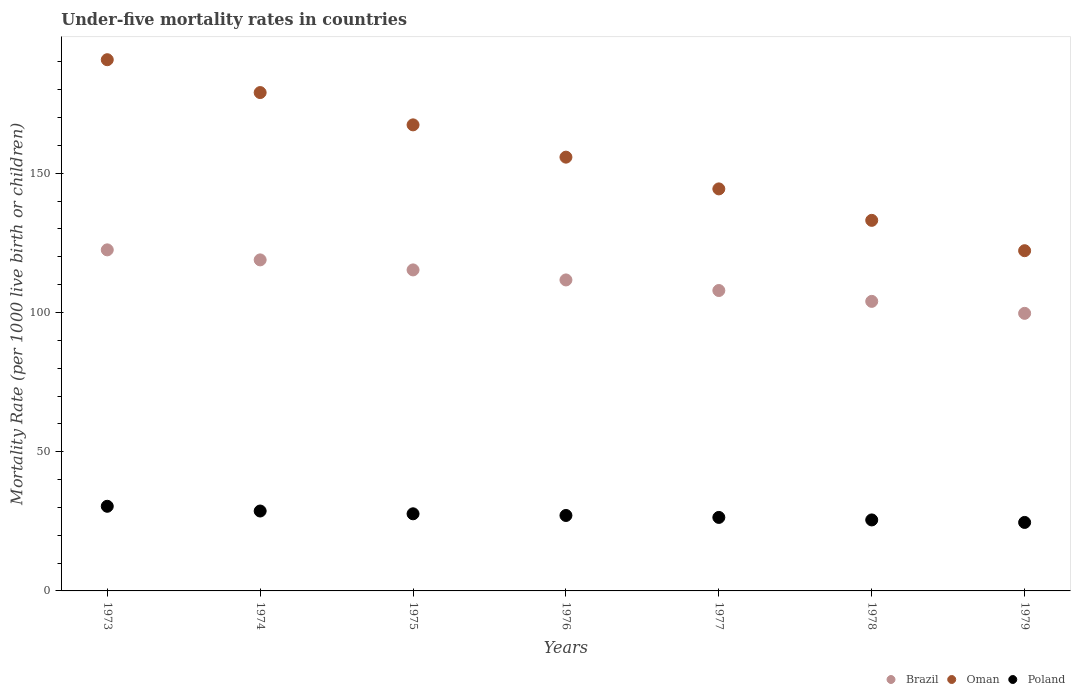How many different coloured dotlines are there?
Make the answer very short. 3. What is the under-five mortality rate in Brazil in 1973?
Your answer should be compact. 122.5. Across all years, what is the maximum under-five mortality rate in Oman?
Provide a succinct answer. 190.8. Across all years, what is the minimum under-five mortality rate in Brazil?
Offer a very short reply. 99.7. In which year was the under-five mortality rate in Oman minimum?
Provide a short and direct response. 1979. What is the total under-five mortality rate in Oman in the graph?
Offer a very short reply. 1092.7. What is the difference between the under-five mortality rate in Poland in 1975 and that in 1978?
Keep it short and to the point. 2.2. What is the difference between the under-five mortality rate in Oman in 1978 and the under-five mortality rate in Brazil in 1974?
Keep it short and to the point. 14.2. What is the average under-five mortality rate in Brazil per year?
Ensure brevity in your answer.  111.43. In the year 1977, what is the difference between the under-five mortality rate in Oman and under-five mortality rate in Brazil?
Your answer should be compact. 36.5. What is the ratio of the under-five mortality rate in Oman in 1975 to that in 1979?
Your answer should be compact. 1.37. What is the difference between the highest and the second highest under-five mortality rate in Poland?
Make the answer very short. 1.7. What is the difference between the highest and the lowest under-five mortality rate in Brazil?
Offer a very short reply. 22.8. Is the under-five mortality rate in Oman strictly greater than the under-five mortality rate in Poland over the years?
Give a very brief answer. Yes. What is the difference between two consecutive major ticks on the Y-axis?
Make the answer very short. 50. Does the graph contain any zero values?
Offer a very short reply. No. Does the graph contain grids?
Make the answer very short. No. Where does the legend appear in the graph?
Keep it short and to the point. Bottom right. How many legend labels are there?
Your answer should be very brief. 3. What is the title of the graph?
Your answer should be very brief. Under-five mortality rates in countries. Does "Tajikistan" appear as one of the legend labels in the graph?
Ensure brevity in your answer.  No. What is the label or title of the Y-axis?
Offer a terse response. Mortality Rate (per 1000 live birth or children). What is the Mortality Rate (per 1000 live birth or children) in Brazil in 1973?
Your answer should be very brief. 122.5. What is the Mortality Rate (per 1000 live birth or children) of Oman in 1973?
Your answer should be compact. 190.8. What is the Mortality Rate (per 1000 live birth or children) in Poland in 1973?
Offer a terse response. 30.4. What is the Mortality Rate (per 1000 live birth or children) of Brazil in 1974?
Your response must be concise. 118.9. What is the Mortality Rate (per 1000 live birth or children) of Oman in 1974?
Make the answer very short. 179. What is the Mortality Rate (per 1000 live birth or children) of Poland in 1974?
Keep it short and to the point. 28.7. What is the Mortality Rate (per 1000 live birth or children) of Brazil in 1975?
Offer a very short reply. 115.3. What is the Mortality Rate (per 1000 live birth or children) of Oman in 1975?
Your answer should be compact. 167.4. What is the Mortality Rate (per 1000 live birth or children) in Poland in 1975?
Your answer should be very brief. 27.7. What is the Mortality Rate (per 1000 live birth or children) of Brazil in 1976?
Offer a very short reply. 111.7. What is the Mortality Rate (per 1000 live birth or children) of Oman in 1976?
Your response must be concise. 155.8. What is the Mortality Rate (per 1000 live birth or children) of Poland in 1976?
Your response must be concise. 27.1. What is the Mortality Rate (per 1000 live birth or children) in Brazil in 1977?
Offer a terse response. 107.9. What is the Mortality Rate (per 1000 live birth or children) in Oman in 1977?
Your answer should be compact. 144.4. What is the Mortality Rate (per 1000 live birth or children) of Poland in 1977?
Offer a very short reply. 26.4. What is the Mortality Rate (per 1000 live birth or children) in Brazil in 1978?
Offer a very short reply. 104. What is the Mortality Rate (per 1000 live birth or children) in Oman in 1978?
Offer a terse response. 133.1. What is the Mortality Rate (per 1000 live birth or children) in Brazil in 1979?
Offer a very short reply. 99.7. What is the Mortality Rate (per 1000 live birth or children) in Oman in 1979?
Offer a very short reply. 122.2. What is the Mortality Rate (per 1000 live birth or children) of Poland in 1979?
Your answer should be very brief. 24.6. Across all years, what is the maximum Mortality Rate (per 1000 live birth or children) of Brazil?
Offer a very short reply. 122.5. Across all years, what is the maximum Mortality Rate (per 1000 live birth or children) in Oman?
Offer a very short reply. 190.8. Across all years, what is the maximum Mortality Rate (per 1000 live birth or children) of Poland?
Your answer should be very brief. 30.4. Across all years, what is the minimum Mortality Rate (per 1000 live birth or children) in Brazil?
Offer a terse response. 99.7. Across all years, what is the minimum Mortality Rate (per 1000 live birth or children) in Oman?
Make the answer very short. 122.2. Across all years, what is the minimum Mortality Rate (per 1000 live birth or children) of Poland?
Your answer should be compact. 24.6. What is the total Mortality Rate (per 1000 live birth or children) of Brazil in the graph?
Provide a short and direct response. 780. What is the total Mortality Rate (per 1000 live birth or children) of Oman in the graph?
Offer a terse response. 1092.7. What is the total Mortality Rate (per 1000 live birth or children) in Poland in the graph?
Give a very brief answer. 190.4. What is the difference between the Mortality Rate (per 1000 live birth or children) of Brazil in 1973 and that in 1974?
Offer a terse response. 3.6. What is the difference between the Mortality Rate (per 1000 live birth or children) in Oman in 1973 and that in 1974?
Make the answer very short. 11.8. What is the difference between the Mortality Rate (per 1000 live birth or children) of Poland in 1973 and that in 1974?
Give a very brief answer. 1.7. What is the difference between the Mortality Rate (per 1000 live birth or children) in Oman in 1973 and that in 1975?
Provide a short and direct response. 23.4. What is the difference between the Mortality Rate (per 1000 live birth or children) in Poland in 1973 and that in 1976?
Your answer should be very brief. 3.3. What is the difference between the Mortality Rate (per 1000 live birth or children) in Oman in 1973 and that in 1977?
Offer a terse response. 46.4. What is the difference between the Mortality Rate (per 1000 live birth or children) of Poland in 1973 and that in 1977?
Provide a succinct answer. 4. What is the difference between the Mortality Rate (per 1000 live birth or children) of Brazil in 1973 and that in 1978?
Give a very brief answer. 18.5. What is the difference between the Mortality Rate (per 1000 live birth or children) of Oman in 1973 and that in 1978?
Offer a very short reply. 57.7. What is the difference between the Mortality Rate (per 1000 live birth or children) in Poland in 1973 and that in 1978?
Give a very brief answer. 4.9. What is the difference between the Mortality Rate (per 1000 live birth or children) of Brazil in 1973 and that in 1979?
Make the answer very short. 22.8. What is the difference between the Mortality Rate (per 1000 live birth or children) in Oman in 1973 and that in 1979?
Offer a terse response. 68.6. What is the difference between the Mortality Rate (per 1000 live birth or children) of Poland in 1973 and that in 1979?
Provide a succinct answer. 5.8. What is the difference between the Mortality Rate (per 1000 live birth or children) of Brazil in 1974 and that in 1975?
Ensure brevity in your answer.  3.6. What is the difference between the Mortality Rate (per 1000 live birth or children) in Oman in 1974 and that in 1975?
Your response must be concise. 11.6. What is the difference between the Mortality Rate (per 1000 live birth or children) of Poland in 1974 and that in 1975?
Ensure brevity in your answer.  1. What is the difference between the Mortality Rate (per 1000 live birth or children) of Oman in 1974 and that in 1976?
Keep it short and to the point. 23.2. What is the difference between the Mortality Rate (per 1000 live birth or children) in Oman in 1974 and that in 1977?
Your response must be concise. 34.6. What is the difference between the Mortality Rate (per 1000 live birth or children) of Brazil in 1974 and that in 1978?
Your answer should be compact. 14.9. What is the difference between the Mortality Rate (per 1000 live birth or children) in Oman in 1974 and that in 1978?
Your response must be concise. 45.9. What is the difference between the Mortality Rate (per 1000 live birth or children) of Poland in 1974 and that in 1978?
Offer a very short reply. 3.2. What is the difference between the Mortality Rate (per 1000 live birth or children) of Oman in 1974 and that in 1979?
Give a very brief answer. 56.8. What is the difference between the Mortality Rate (per 1000 live birth or children) in Poland in 1974 and that in 1979?
Provide a short and direct response. 4.1. What is the difference between the Mortality Rate (per 1000 live birth or children) of Oman in 1975 and that in 1976?
Ensure brevity in your answer.  11.6. What is the difference between the Mortality Rate (per 1000 live birth or children) in Brazil in 1975 and that in 1977?
Offer a very short reply. 7.4. What is the difference between the Mortality Rate (per 1000 live birth or children) in Oman in 1975 and that in 1978?
Give a very brief answer. 34.3. What is the difference between the Mortality Rate (per 1000 live birth or children) of Brazil in 1975 and that in 1979?
Your answer should be very brief. 15.6. What is the difference between the Mortality Rate (per 1000 live birth or children) of Oman in 1975 and that in 1979?
Offer a terse response. 45.2. What is the difference between the Mortality Rate (per 1000 live birth or children) in Poland in 1975 and that in 1979?
Offer a very short reply. 3.1. What is the difference between the Mortality Rate (per 1000 live birth or children) in Brazil in 1976 and that in 1977?
Your answer should be very brief. 3.8. What is the difference between the Mortality Rate (per 1000 live birth or children) in Poland in 1976 and that in 1977?
Make the answer very short. 0.7. What is the difference between the Mortality Rate (per 1000 live birth or children) of Brazil in 1976 and that in 1978?
Your answer should be compact. 7.7. What is the difference between the Mortality Rate (per 1000 live birth or children) of Oman in 1976 and that in 1978?
Give a very brief answer. 22.7. What is the difference between the Mortality Rate (per 1000 live birth or children) in Oman in 1976 and that in 1979?
Your answer should be compact. 33.6. What is the difference between the Mortality Rate (per 1000 live birth or children) of Poland in 1976 and that in 1979?
Give a very brief answer. 2.5. What is the difference between the Mortality Rate (per 1000 live birth or children) in Oman in 1977 and that in 1978?
Your response must be concise. 11.3. What is the difference between the Mortality Rate (per 1000 live birth or children) of Poland in 1977 and that in 1978?
Ensure brevity in your answer.  0.9. What is the difference between the Mortality Rate (per 1000 live birth or children) of Brazil in 1977 and that in 1979?
Provide a short and direct response. 8.2. What is the difference between the Mortality Rate (per 1000 live birth or children) of Poland in 1977 and that in 1979?
Your response must be concise. 1.8. What is the difference between the Mortality Rate (per 1000 live birth or children) of Brazil in 1978 and that in 1979?
Make the answer very short. 4.3. What is the difference between the Mortality Rate (per 1000 live birth or children) in Brazil in 1973 and the Mortality Rate (per 1000 live birth or children) in Oman in 1974?
Ensure brevity in your answer.  -56.5. What is the difference between the Mortality Rate (per 1000 live birth or children) in Brazil in 1973 and the Mortality Rate (per 1000 live birth or children) in Poland in 1974?
Ensure brevity in your answer.  93.8. What is the difference between the Mortality Rate (per 1000 live birth or children) in Oman in 1973 and the Mortality Rate (per 1000 live birth or children) in Poland in 1974?
Give a very brief answer. 162.1. What is the difference between the Mortality Rate (per 1000 live birth or children) of Brazil in 1973 and the Mortality Rate (per 1000 live birth or children) of Oman in 1975?
Provide a succinct answer. -44.9. What is the difference between the Mortality Rate (per 1000 live birth or children) of Brazil in 1973 and the Mortality Rate (per 1000 live birth or children) of Poland in 1975?
Your response must be concise. 94.8. What is the difference between the Mortality Rate (per 1000 live birth or children) of Oman in 1973 and the Mortality Rate (per 1000 live birth or children) of Poland in 1975?
Offer a very short reply. 163.1. What is the difference between the Mortality Rate (per 1000 live birth or children) of Brazil in 1973 and the Mortality Rate (per 1000 live birth or children) of Oman in 1976?
Provide a succinct answer. -33.3. What is the difference between the Mortality Rate (per 1000 live birth or children) of Brazil in 1973 and the Mortality Rate (per 1000 live birth or children) of Poland in 1976?
Give a very brief answer. 95.4. What is the difference between the Mortality Rate (per 1000 live birth or children) in Oman in 1973 and the Mortality Rate (per 1000 live birth or children) in Poland in 1976?
Keep it short and to the point. 163.7. What is the difference between the Mortality Rate (per 1000 live birth or children) of Brazil in 1973 and the Mortality Rate (per 1000 live birth or children) of Oman in 1977?
Offer a very short reply. -21.9. What is the difference between the Mortality Rate (per 1000 live birth or children) of Brazil in 1973 and the Mortality Rate (per 1000 live birth or children) of Poland in 1977?
Give a very brief answer. 96.1. What is the difference between the Mortality Rate (per 1000 live birth or children) in Oman in 1973 and the Mortality Rate (per 1000 live birth or children) in Poland in 1977?
Your answer should be compact. 164.4. What is the difference between the Mortality Rate (per 1000 live birth or children) in Brazil in 1973 and the Mortality Rate (per 1000 live birth or children) in Oman in 1978?
Keep it short and to the point. -10.6. What is the difference between the Mortality Rate (per 1000 live birth or children) in Brazil in 1973 and the Mortality Rate (per 1000 live birth or children) in Poland in 1978?
Provide a succinct answer. 97. What is the difference between the Mortality Rate (per 1000 live birth or children) of Oman in 1973 and the Mortality Rate (per 1000 live birth or children) of Poland in 1978?
Keep it short and to the point. 165.3. What is the difference between the Mortality Rate (per 1000 live birth or children) of Brazil in 1973 and the Mortality Rate (per 1000 live birth or children) of Poland in 1979?
Keep it short and to the point. 97.9. What is the difference between the Mortality Rate (per 1000 live birth or children) in Oman in 1973 and the Mortality Rate (per 1000 live birth or children) in Poland in 1979?
Ensure brevity in your answer.  166.2. What is the difference between the Mortality Rate (per 1000 live birth or children) in Brazil in 1974 and the Mortality Rate (per 1000 live birth or children) in Oman in 1975?
Provide a short and direct response. -48.5. What is the difference between the Mortality Rate (per 1000 live birth or children) of Brazil in 1974 and the Mortality Rate (per 1000 live birth or children) of Poland in 1975?
Provide a short and direct response. 91.2. What is the difference between the Mortality Rate (per 1000 live birth or children) of Oman in 1974 and the Mortality Rate (per 1000 live birth or children) of Poland in 1975?
Provide a succinct answer. 151.3. What is the difference between the Mortality Rate (per 1000 live birth or children) of Brazil in 1974 and the Mortality Rate (per 1000 live birth or children) of Oman in 1976?
Offer a terse response. -36.9. What is the difference between the Mortality Rate (per 1000 live birth or children) of Brazil in 1974 and the Mortality Rate (per 1000 live birth or children) of Poland in 1976?
Make the answer very short. 91.8. What is the difference between the Mortality Rate (per 1000 live birth or children) in Oman in 1974 and the Mortality Rate (per 1000 live birth or children) in Poland in 1976?
Keep it short and to the point. 151.9. What is the difference between the Mortality Rate (per 1000 live birth or children) of Brazil in 1974 and the Mortality Rate (per 1000 live birth or children) of Oman in 1977?
Ensure brevity in your answer.  -25.5. What is the difference between the Mortality Rate (per 1000 live birth or children) in Brazil in 1974 and the Mortality Rate (per 1000 live birth or children) in Poland in 1977?
Your answer should be compact. 92.5. What is the difference between the Mortality Rate (per 1000 live birth or children) in Oman in 1974 and the Mortality Rate (per 1000 live birth or children) in Poland in 1977?
Offer a terse response. 152.6. What is the difference between the Mortality Rate (per 1000 live birth or children) of Brazil in 1974 and the Mortality Rate (per 1000 live birth or children) of Oman in 1978?
Provide a short and direct response. -14.2. What is the difference between the Mortality Rate (per 1000 live birth or children) in Brazil in 1974 and the Mortality Rate (per 1000 live birth or children) in Poland in 1978?
Keep it short and to the point. 93.4. What is the difference between the Mortality Rate (per 1000 live birth or children) in Oman in 1974 and the Mortality Rate (per 1000 live birth or children) in Poland in 1978?
Your response must be concise. 153.5. What is the difference between the Mortality Rate (per 1000 live birth or children) in Brazil in 1974 and the Mortality Rate (per 1000 live birth or children) in Poland in 1979?
Your answer should be compact. 94.3. What is the difference between the Mortality Rate (per 1000 live birth or children) of Oman in 1974 and the Mortality Rate (per 1000 live birth or children) of Poland in 1979?
Your response must be concise. 154.4. What is the difference between the Mortality Rate (per 1000 live birth or children) in Brazil in 1975 and the Mortality Rate (per 1000 live birth or children) in Oman in 1976?
Provide a short and direct response. -40.5. What is the difference between the Mortality Rate (per 1000 live birth or children) in Brazil in 1975 and the Mortality Rate (per 1000 live birth or children) in Poland in 1976?
Provide a succinct answer. 88.2. What is the difference between the Mortality Rate (per 1000 live birth or children) in Oman in 1975 and the Mortality Rate (per 1000 live birth or children) in Poland in 1976?
Give a very brief answer. 140.3. What is the difference between the Mortality Rate (per 1000 live birth or children) of Brazil in 1975 and the Mortality Rate (per 1000 live birth or children) of Oman in 1977?
Your response must be concise. -29.1. What is the difference between the Mortality Rate (per 1000 live birth or children) in Brazil in 1975 and the Mortality Rate (per 1000 live birth or children) in Poland in 1977?
Give a very brief answer. 88.9. What is the difference between the Mortality Rate (per 1000 live birth or children) in Oman in 1975 and the Mortality Rate (per 1000 live birth or children) in Poland in 1977?
Provide a succinct answer. 141. What is the difference between the Mortality Rate (per 1000 live birth or children) in Brazil in 1975 and the Mortality Rate (per 1000 live birth or children) in Oman in 1978?
Make the answer very short. -17.8. What is the difference between the Mortality Rate (per 1000 live birth or children) of Brazil in 1975 and the Mortality Rate (per 1000 live birth or children) of Poland in 1978?
Keep it short and to the point. 89.8. What is the difference between the Mortality Rate (per 1000 live birth or children) of Oman in 1975 and the Mortality Rate (per 1000 live birth or children) of Poland in 1978?
Offer a terse response. 141.9. What is the difference between the Mortality Rate (per 1000 live birth or children) in Brazil in 1975 and the Mortality Rate (per 1000 live birth or children) in Oman in 1979?
Offer a very short reply. -6.9. What is the difference between the Mortality Rate (per 1000 live birth or children) in Brazil in 1975 and the Mortality Rate (per 1000 live birth or children) in Poland in 1979?
Offer a terse response. 90.7. What is the difference between the Mortality Rate (per 1000 live birth or children) in Oman in 1975 and the Mortality Rate (per 1000 live birth or children) in Poland in 1979?
Your response must be concise. 142.8. What is the difference between the Mortality Rate (per 1000 live birth or children) in Brazil in 1976 and the Mortality Rate (per 1000 live birth or children) in Oman in 1977?
Make the answer very short. -32.7. What is the difference between the Mortality Rate (per 1000 live birth or children) of Brazil in 1976 and the Mortality Rate (per 1000 live birth or children) of Poland in 1977?
Provide a succinct answer. 85.3. What is the difference between the Mortality Rate (per 1000 live birth or children) of Oman in 1976 and the Mortality Rate (per 1000 live birth or children) of Poland in 1977?
Your answer should be compact. 129.4. What is the difference between the Mortality Rate (per 1000 live birth or children) of Brazil in 1976 and the Mortality Rate (per 1000 live birth or children) of Oman in 1978?
Give a very brief answer. -21.4. What is the difference between the Mortality Rate (per 1000 live birth or children) of Brazil in 1976 and the Mortality Rate (per 1000 live birth or children) of Poland in 1978?
Offer a very short reply. 86.2. What is the difference between the Mortality Rate (per 1000 live birth or children) of Oman in 1976 and the Mortality Rate (per 1000 live birth or children) of Poland in 1978?
Offer a terse response. 130.3. What is the difference between the Mortality Rate (per 1000 live birth or children) of Brazil in 1976 and the Mortality Rate (per 1000 live birth or children) of Poland in 1979?
Ensure brevity in your answer.  87.1. What is the difference between the Mortality Rate (per 1000 live birth or children) in Oman in 1976 and the Mortality Rate (per 1000 live birth or children) in Poland in 1979?
Your answer should be compact. 131.2. What is the difference between the Mortality Rate (per 1000 live birth or children) in Brazil in 1977 and the Mortality Rate (per 1000 live birth or children) in Oman in 1978?
Give a very brief answer. -25.2. What is the difference between the Mortality Rate (per 1000 live birth or children) of Brazil in 1977 and the Mortality Rate (per 1000 live birth or children) of Poland in 1978?
Keep it short and to the point. 82.4. What is the difference between the Mortality Rate (per 1000 live birth or children) in Oman in 1977 and the Mortality Rate (per 1000 live birth or children) in Poland in 1978?
Make the answer very short. 118.9. What is the difference between the Mortality Rate (per 1000 live birth or children) in Brazil in 1977 and the Mortality Rate (per 1000 live birth or children) in Oman in 1979?
Keep it short and to the point. -14.3. What is the difference between the Mortality Rate (per 1000 live birth or children) of Brazil in 1977 and the Mortality Rate (per 1000 live birth or children) of Poland in 1979?
Offer a very short reply. 83.3. What is the difference between the Mortality Rate (per 1000 live birth or children) in Oman in 1977 and the Mortality Rate (per 1000 live birth or children) in Poland in 1979?
Your answer should be very brief. 119.8. What is the difference between the Mortality Rate (per 1000 live birth or children) of Brazil in 1978 and the Mortality Rate (per 1000 live birth or children) of Oman in 1979?
Provide a short and direct response. -18.2. What is the difference between the Mortality Rate (per 1000 live birth or children) of Brazil in 1978 and the Mortality Rate (per 1000 live birth or children) of Poland in 1979?
Provide a succinct answer. 79.4. What is the difference between the Mortality Rate (per 1000 live birth or children) in Oman in 1978 and the Mortality Rate (per 1000 live birth or children) in Poland in 1979?
Offer a terse response. 108.5. What is the average Mortality Rate (per 1000 live birth or children) of Brazil per year?
Give a very brief answer. 111.43. What is the average Mortality Rate (per 1000 live birth or children) in Oman per year?
Your response must be concise. 156.1. What is the average Mortality Rate (per 1000 live birth or children) of Poland per year?
Your answer should be compact. 27.2. In the year 1973, what is the difference between the Mortality Rate (per 1000 live birth or children) in Brazil and Mortality Rate (per 1000 live birth or children) in Oman?
Offer a very short reply. -68.3. In the year 1973, what is the difference between the Mortality Rate (per 1000 live birth or children) of Brazil and Mortality Rate (per 1000 live birth or children) of Poland?
Offer a very short reply. 92.1. In the year 1973, what is the difference between the Mortality Rate (per 1000 live birth or children) in Oman and Mortality Rate (per 1000 live birth or children) in Poland?
Provide a succinct answer. 160.4. In the year 1974, what is the difference between the Mortality Rate (per 1000 live birth or children) of Brazil and Mortality Rate (per 1000 live birth or children) of Oman?
Give a very brief answer. -60.1. In the year 1974, what is the difference between the Mortality Rate (per 1000 live birth or children) in Brazil and Mortality Rate (per 1000 live birth or children) in Poland?
Provide a short and direct response. 90.2. In the year 1974, what is the difference between the Mortality Rate (per 1000 live birth or children) of Oman and Mortality Rate (per 1000 live birth or children) of Poland?
Provide a short and direct response. 150.3. In the year 1975, what is the difference between the Mortality Rate (per 1000 live birth or children) of Brazil and Mortality Rate (per 1000 live birth or children) of Oman?
Give a very brief answer. -52.1. In the year 1975, what is the difference between the Mortality Rate (per 1000 live birth or children) in Brazil and Mortality Rate (per 1000 live birth or children) in Poland?
Your answer should be compact. 87.6. In the year 1975, what is the difference between the Mortality Rate (per 1000 live birth or children) of Oman and Mortality Rate (per 1000 live birth or children) of Poland?
Offer a very short reply. 139.7. In the year 1976, what is the difference between the Mortality Rate (per 1000 live birth or children) of Brazil and Mortality Rate (per 1000 live birth or children) of Oman?
Provide a succinct answer. -44.1. In the year 1976, what is the difference between the Mortality Rate (per 1000 live birth or children) of Brazil and Mortality Rate (per 1000 live birth or children) of Poland?
Provide a succinct answer. 84.6. In the year 1976, what is the difference between the Mortality Rate (per 1000 live birth or children) in Oman and Mortality Rate (per 1000 live birth or children) in Poland?
Your answer should be compact. 128.7. In the year 1977, what is the difference between the Mortality Rate (per 1000 live birth or children) in Brazil and Mortality Rate (per 1000 live birth or children) in Oman?
Make the answer very short. -36.5. In the year 1977, what is the difference between the Mortality Rate (per 1000 live birth or children) of Brazil and Mortality Rate (per 1000 live birth or children) of Poland?
Offer a terse response. 81.5. In the year 1977, what is the difference between the Mortality Rate (per 1000 live birth or children) of Oman and Mortality Rate (per 1000 live birth or children) of Poland?
Make the answer very short. 118. In the year 1978, what is the difference between the Mortality Rate (per 1000 live birth or children) of Brazil and Mortality Rate (per 1000 live birth or children) of Oman?
Your response must be concise. -29.1. In the year 1978, what is the difference between the Mortality Rate (per 1000 live birth or children) in Brazil and Mortality Rate (per 1000 live birth or children) in Poland?
Offer a very short reply. 78.5. In the year 1978, what is the difference between the Mortality Rate (per 1000 live birth or children) in Oman and Mortality Rate (per 1000 live birth or children) in Poland?
Offer a very short reply. 107.6. In the year 1979, what is the difference between the Mortality Rate (per 1000 live birth or children) of Brazil and Mortality Rate (per 1000 live birth or children) of Oman?
Make the answer very short. -22.5. In the year 1979, what is the difference between the Mortality Rate (per 1000 live birth or children) of Brazil and Mortality Rate (per 1000 live birth or children) of Poland?
Provide a short and direct response. 75.1. In the year 1979, what is the difference between the Mortality Rate (per 1000 live birth or children) in Oman and Mortality Rate (per 1000 live birth or children) in Poland?
Offer a terse response. 97.6. What is the ratio of the Mortality Rate (per 1000 live birth or children) of Brazil in 1973 to that in 1974?
Your answer should be compact. 1.03. What is the ratio of the Mortality Rate (per 1000 live birth or children) of Oman in 1973 to that in 1974?
Provide a succinct answer. 1.07. What is the ratio of the Mortality Rate (per 1000 live birth or children) in Poland in 1973 to that in 1974?
Provide a short and direct response. 1.06. What is the ratio of the Mortality Rate (per 1000 live birth or children) of Brazil in 1973 to that in 1975?
Offer a terse response. 1.06. What is the ratio of the Mortality Rate (per 1000 live birth or children) of Oman in 1973 to that in 1975?
Offer a very short reply. 1.14. What is the ratio of the Mortality Rate (per 1000 live birth or children) in Poland in 1973 to that in 1975?
Your answer should be compact. 1.1. What is the ratio of the Mortality Rate (per 1000 live birth or children) in Brazil in 1973 to that in 1976?
Give a very brief answer. 1.1. What is the ratio of the Mortality Rate (per 1000 live birth or children) in Oman in 1973 to that in 1976?
Provide a succinct answer. 1.22. What is the ratio of the Mortality Rate (per 1000 live birth or children) in Poland in 1973 to that in 1976?
Provide a short and direct response. 1.12. What is the ratio of the Mortality Rate (per 1000 live birth or children) of Brazil in 1973 to that in 1977?
Your response must be concise. 1.14. What is the ratio of the Mortality Rate (per 1000 live birth or children) in Oman in 1973 to that in 1977?
Ensure brevity in your answer.  1.32. What is the ratio of the Mortality Rate (per 1000 live birth or children) of Poland in 1973 to that in 1977?
Provide a succinct answer. 1.15. What is the ratio of the Mortality Rate (per 1000 live birth or children) in Brazil in 1973 to that in 1978?
Provide a succinct answer. 1.18. What is the ratio of the Mortality Rate (per 1000 live birth or children) in Oman in 1973 to that in 1978?
Your answer should be compact. 1.43. What is the ratio of the Mortality Rate (per 1000 live birth or children) of Poland in 1973 to that in 1978?
Give a very brief answer. 1.19. What is the ratio of the Mortality Rate (per 1000 live birth or children) of Brazil in 1973 to that in 1979?
Provide a succinct answer. 1.23. What is the ratio of the Mortality Rate (per 1000 live birth or children) of Oman in 1973 to that in 1979?
Make the answer very short. 1.56. What is the ratio of the Mortality Rate (per 1000 live birth or children) in Poland in 1973 to that in 1979?
Provide a succinct answer. 1.24. What is the ratio of the Mortality Rate (per 1000 live birth or children) of Brazil in 1974 to that in 1975?
Your response must be concise. 1.03. What is the ratio of the Mortality Rate (per 1000 live birth or children) of Oman in 1974 to that in 1975?
Keep it short and to the point. 1.07. What is the ratio of the Mortality Rate (per 1000 live birth or children) in Poland in 1974 to that in 1975?
Provide a short and direct response. 1.04. What is the ratio of the Mortality Rate (per 1000 live birth or children) in Brazil in 1974 to that in 1976?
Provide a short and direct response. 1.06. What is the ratio of the Mortality Rate (per 1000 live birth or children) of Oman in 1974 to that in 1976?
Your answer should be compact. 1.15. What is the ratio of the Mortality Rate (per 1000 live birth or children) of Poland in 1974 to that in 1976?
Make the answer very short. 1.06. What is the ratio of the Mortality Rate (per 1000 live birth or children) of Brazil in 1974 to that in 1977?
Make the answer very short. 1.1. What is the ratio of the Mortality Rate (per 1000 live birth or children) of Oman in 1974 to that in 1977?
Give a very brief answer. 1.24. What is the ratio of the Mortality Rate (per 1000 live birth or children) in Poland in 1974 to that in 1977?
Your answer should be very brief. 1.09. What is the ratio of the Mortality Rate (per 1000 live birth or children) in Brazil in 1974 to that in 1978?
Offer a terse response. 1.14. What is the ratio of the Mortality Rate (per 1000 live birth or children) of Oman in 1974 to that in 1978?
Provide a succinct answer. 1.34. What is the ratio of the Mortality Rate (per 1000 live birth or children) in Poland in 1974 to that in 1978?
Make the answer very short. 1.13. What is the ratio of the Mortality Rate (per 1000 live birth or children) in Brazil in 1974 to that in 1979?
Give a very brief answer. 1.19. What is the ratio of the Mortality Rate (per 1000 live birth or children) in Oman in 1974 to that in 1979?
Your answer should be very brief. 1.46. What is the ratio of the Mortality Rate (per 1000 live birth or children) of Poland in 1974 to that in 1979?
Give a very brief answer. 1.17. What is the ratio of the Mortality Rate (per 1000 live birth or children) of Brazil in 1975 to that in 1976?
Give a very brief answer. 1.03. What is the ratio of the Mortality Rate (per 1000 live birth or children) in Oman in 1975 to that in 1976?
Keep it short and to the point. 1.07. What is the ratio of the Mortality Rate (per 1000 live birth or children) of Poland in 1975 to that in 1976?
Provide a succinct answer. 1.02. What is the ratio of the Mortality Rate (per 1000 live birth or children) in Brazil in 1975 to that in 1977?
Ensure brevity in your answer.  1.07. What is the ratio of the Mortality Rate (per 1000 live birth or children) in Oman in 1975 to that in 1977?
Keep it short and to the point. 1.16. What is the ratio of the Mortality Rate (per 1000 live birth or children) of Poland in 1975 to that in 1977?
Provide a short and direct response. 1.05. What is the ratio of the Mortality Rate (per 1000 live birth or children) of Brazil in 1975 to that in 1978?
Your response must be concise. 1.11. What is the ratio of the Mortality Rate (per 1000 live birth or children) of Oman in 1975 to that in 1978?
Offer a very short reply. 1.26. What is the ratio of the Mortality Rate (per 1000 live birth or children) of Poland in 1975 to that in 1978?
Give a very brief answer. 1.09. What is the ratio of the Mortality Rate (per 1000 live birth or children) in Brazil in 1975 to that in 1979?
Keep it short and to the point. 1.16. What is the ratio of the Mortality Rate (per 1000 live birth or children) of Oman in 1975 to that in 1979?
Your response must be concise. 1.37. What is the ratio of the Mortality Rate (per 1000 live birth or children) in Poland in 1975 to that in 1979?
Offer a terse response. 1.13. What is the ratio of the Mortality Rate (per 1000 live birth or children) in Brazil in 1976 to that in 1977?
Your answer should be compact. 1.04. What is the ratio of the Mortality Rate (per 1000 live birth or children) of Oman in 1976 to that in 1977?
Your response must be concise. 1.08. What is the ratio of the Mortality Rate (per 1000 live birth or children) of Poland in 1976 to that in 1977?
Make the answer very short. 1.03. What is the ratio of the Mortality Rate (per 1000 live birth or children) in Brazil in 1976 to that in 1978?
Provide a succinct answer. 1.07. What is the ratio of the Mortality Rate (per 1000 live birth or children) of Oman in 1976 to that in 1978?
Ensure brevity in your answer.  1.17. What is the ratio of the Mortality Rate (per 1000 live birth or children) of Poland in 1976 to that in 1978?
Your response must be concise. 1.06. What is the ratio of the Mortality Rate (per 1000 live birth or children) of Brazil in 1976 to that in 1979?
Keep it short and to the point. 1.12. What is the ratio of the Mortality Rate (per 1000 live birth or children) in Oman in 1976 to that in 1979?
Provide a short and direct response. 1.27. What is the ratio of the Mortality Rate (per 1000 live birth or children) of Poland in 1976 to that in 1979?
Keep it short and to the point. 1.1. What is the ratio of the Mortality Rate (per 1000 live birth or children) of Brazil in 1977 to that in 1978?
Keep it short and to the point. 1.04. What is the ratio of the Mortality Rate (per 1000 live birth or children) in Oman in 1977 to that in 1978?
Provide a succinct answer. 1.08. What is the ratio of the Mortality Rate (per 1000 live birth or children) of Poland in 1977 to that in 1978?
Ensure brevity in your answer.  1.04. What is the ratio of the Mortality Rate (per 1000 live birth or children) in Brazil in 1977 to that in 1979?
Ensure brevity in your answer.  1.08. What is the ratio of the Mortality Rate (per 1000 live birth or children) in Oman in 1977 to that in 1979?
Your response must be concise. 1.18. What is the ratio of the Mortality Rate (per 1000 live birth or children) in Poland in 1977 to that in 1979?
Keep it short and to the point. 1.07. What is the ratio of the Mortality Rate (per 1000 live birth or children) of Brazil in 1978 to that in 1979?
Provide a succinct answer. 1.04. What is the ratio of the Mortality Rate (per 1000 live birth or children) of Oman in 1978 to that in 1979?
Your answer should be compact. 1.09. What is the ratio of the Mortality Rate (per 1000 live birth or children) in Poland in 1978 to that in 1979?
Provide a short and direct response. 1.04. What is the difference between the highest and the second highest Mortality Rate (per 1000 live birth or children) of Oman?
Your answer should be compact. 11.8. What is the difference between the highest and the second highest Mortality Rate (per 1000 live birth or children) in Poland?
Provide a short and direct response. 1.7. What is the difference between the highest and the lowest Mortality Rate (per 1000 live birth or children) in Brazil?
Provide a succinct answer. 22.8. What is the difference between the highest and the lowest Mortality Rate (per 1000 live birth or children) in Oman?
Give a very brief answer. 68.6. 